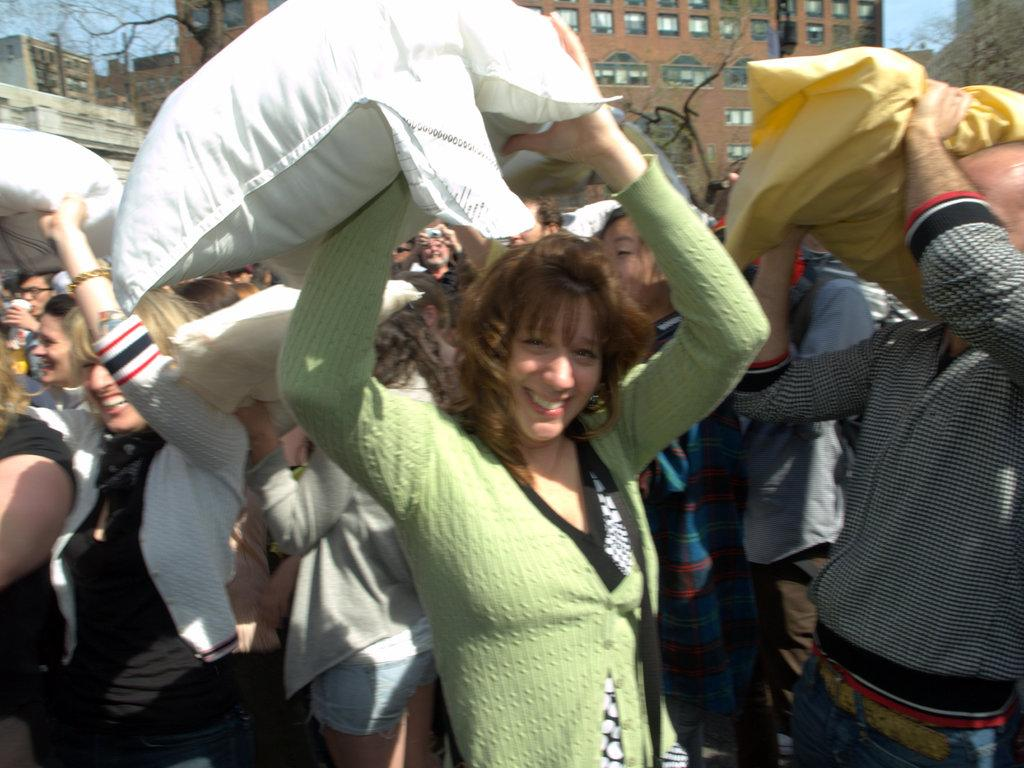What are the persons in the image holding? The persons in the image are holding an object in their hands. What can be seen in the background of the image? There are buildings and dried trees with no leaves in the background. What direction is the spy moving in the image? There is no spy present in the image, so it is not possible to determine the direction in which they might be moving. 